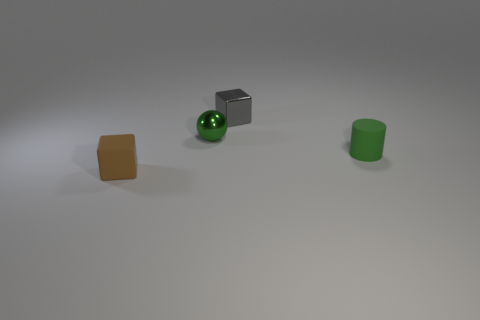The other object that is the same shape as the tiny gray thing is what size?
Offer a terse response. Small. There is a small object that is both right of the small metal sphere and left of the cylinder; what material is it?
Make the answer very short. Metal. Are there the same number of tiny gray shiny blocks in front of the green cylinder and tiny cyan objects?
Offer a terse response. Yes. What number of objects are either small blocks left of the small metal sphere or small yellow metallic things?
Your answer should be very brief. 1. There is a block that is behind the tiny brown object; does it have the same color as the small matte cylinder?
Offer a terse response. No. What is the size of the rubber object that is in front of the small green cylinder?
Ensure brevity in your answer.  Small. There is a matte object that is behind the cube in front of the small gray shiny object; what is its shape?
Your answer should be compact. Cylinder. There is another tiny matte thing that is the same shape as the gray thing; what is its color?
Provide a succinct answer. Brown. There is a brown object in front of the green shiny sphere; is its size the same as the green shiny thing?
Provide a succinct answer. Yes. What is the shape of the small rubber object that is the same color as the tiny sphere?
Your answer should be compact. Cylinder. 